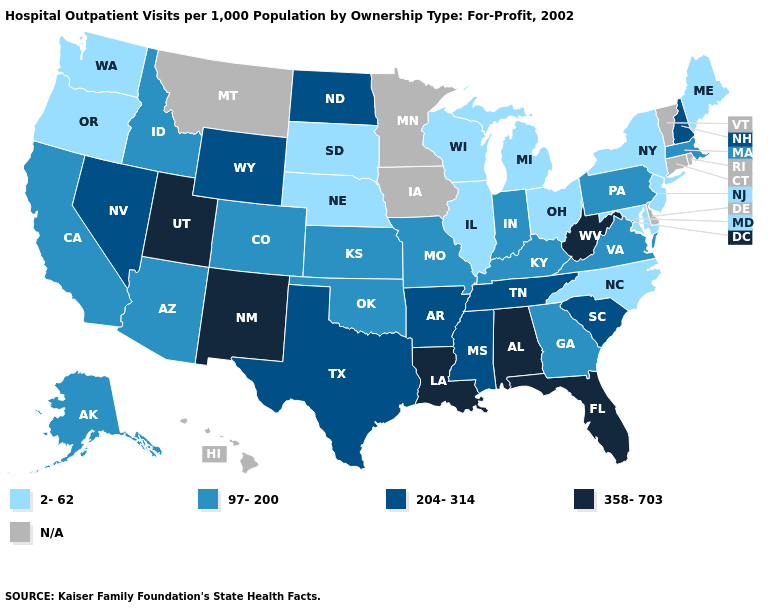What is the value of Delaware?
Concise answer only. N/A. Name the states that have a value in the range 97-200?
Concise answer only. Alaska, Arizona, California, Colorado, Georgia, Idaho, Indiana, Kansas, Kentucky, Massachusetts, Missouri, Oklahoma, Pennsylvania, Virginia. What is the value of Montana?
Concise answer only. N/A. What is the value of Oklahoma?
Write a very short answer. 97-200. Among the states that border Delaware , which have the highest value?
Give a very brief answer. Pennsylvania. What is the value of Maine?
Be succinct. 2-62. Name the states that have a value in the range 2-62?
Give a very brief answer. Illinois, Maine, Maryland, Michigan, Nebraska, New Jersey, New York, North Carolina, Ohio, Oregon, South Dakota, Washington, Wisconsin. Name the states that have a value in the range 358-703?
Concise answer only. Alabama, Florida, Louisiana, New Mexico, Utah, West Virginia. What is the value of Arizona?
Quick response, please. 97-200. Name the states that have a value in the range 97-200?
Write a very short answer. Alaska, Arizona, California, Colorado, Georgia, Idaho, Indiana, Kansas, Kentucky, Massachusetts, Missouri, Oklahoma, Pennsylvania, Virginia. Name the states that have a value in the range N/A?
Keep it brief. Connecticut, Delaware, Hawaii, Iowa, Minnesota, Montana, Rhode Island, Vermont. Name the states that have a value in the range 97-200?
Write a very short answer. Alaska, Arizona, California, Colorado, Georgia, Idaho, Indiana, Kansas, Kentucky, Massachusetts, Missouri, Oklahoma, Pennsylvania, Virginia. Name the states that have a value in the range N/A?
Be succinct. Connecticut, Delaware, Hawaii, Iowa, Minnesota, Montana, Rhode Island, Vermont. Name the states that have a value in the range 97-200?
Concise answer only. Alaska, Arizona, California, Colorado, Georgia, Idaho, Indiana, Kansas, Kentucky, Massachusetts, Missouri, Oklahoma, Pennsylvania, Virginia. 